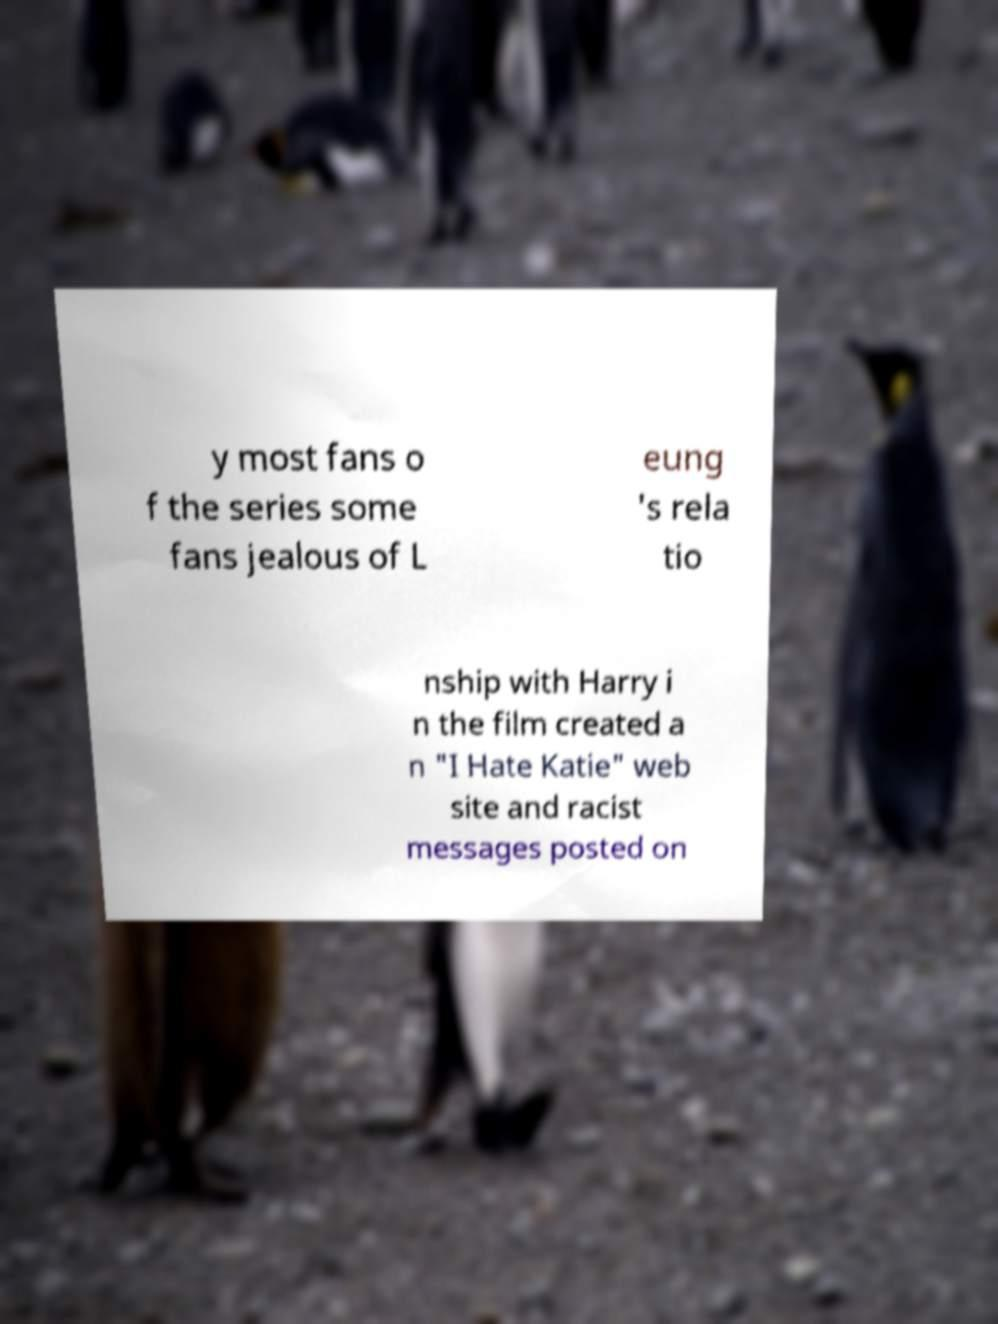What messages or text are displayed in this image? I need them in a readable, typed format. y most fans o f the series some fans jealous of L eung 's rela tio nship with Harry i n the film created a n "I Hate Katie" web site and racist messages posted on 